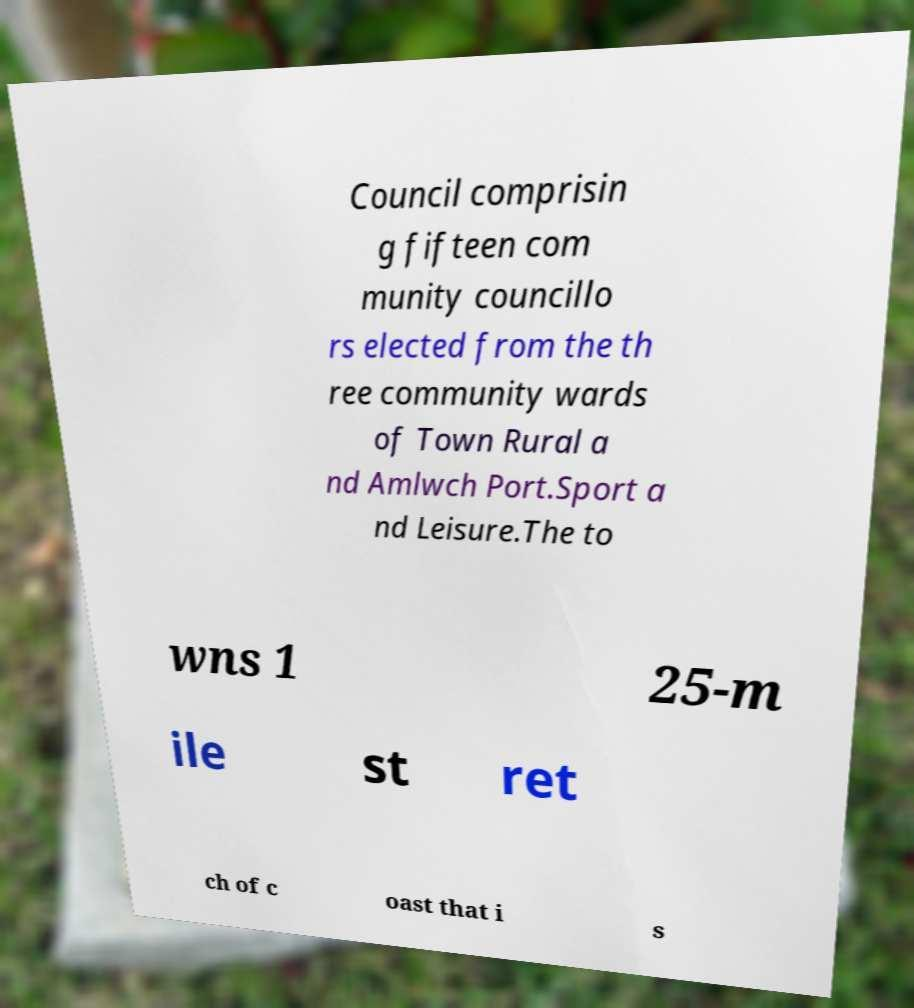Could you extract and type out the text from this image? Council comprisin g fifteen com munity councillo rs elected from the th ree community wards of Town Rural a nd Amlwch Port.Sport a nd Leisure.The to wns 1 25-m ile st ret ch of c oast that i s 